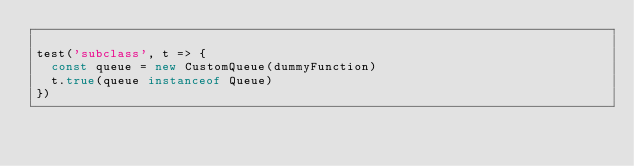<code> <loc_0><loc_0><loc_500><loc_500><_JavaScript_>
test('subclass', t => {
  const queue = new CustomQueue(dummyFunction)
  t.true(queue instanceof Queue)
})
</code> 